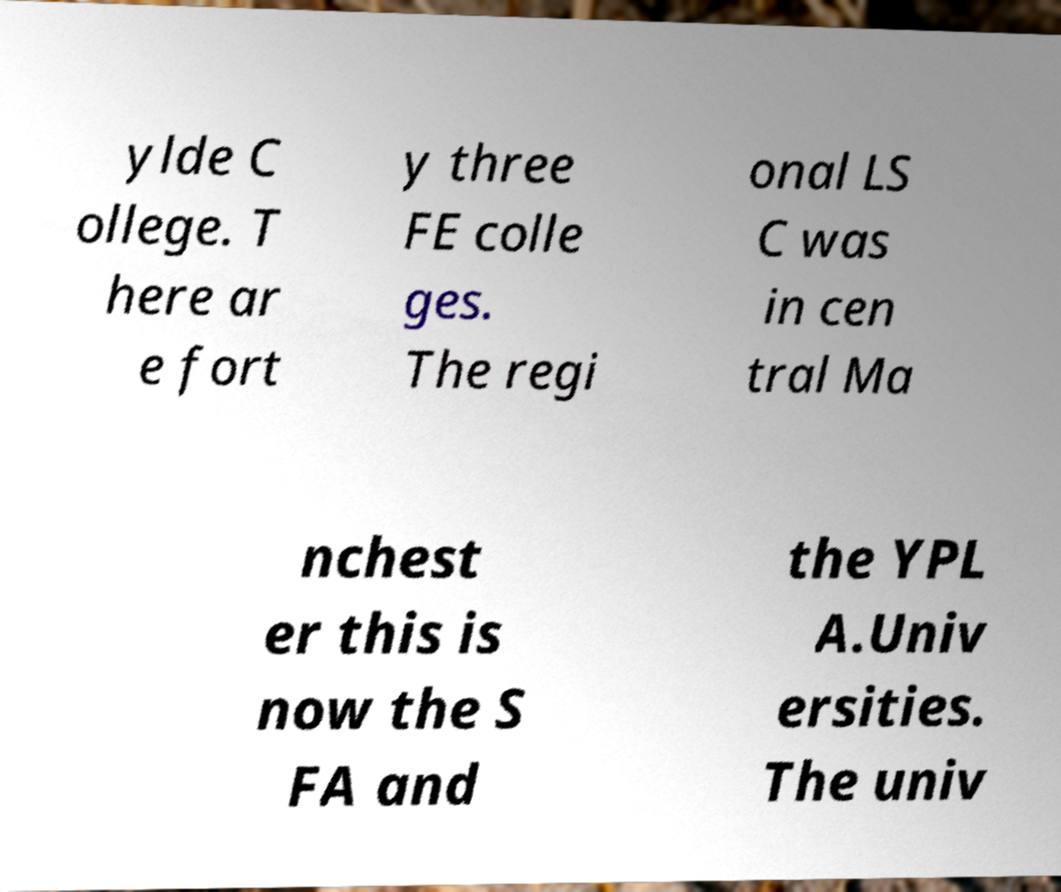Could you extract and type out the text from this image? ylde C ollege. T here ar e fort y three FE colle ges. The regi onal LS C was in cen tral Ma nchest er this is now the S FA and the YPL A.Univ ersities. The univ 